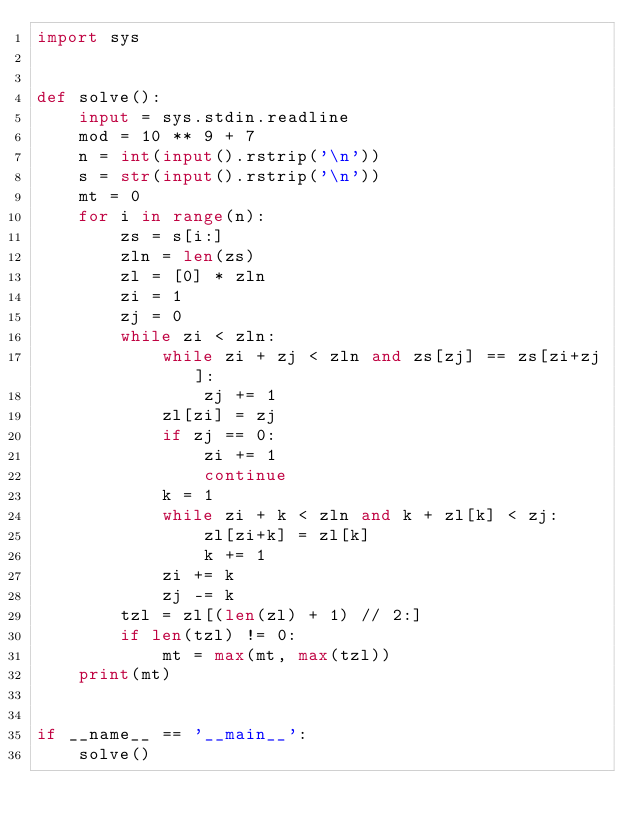Convert code to text. <code><loc_0><loc_0><loc_500><loc_500><_Python_>import sys


def solve():
    input = sys.stdin.readline
    mod = 10 ** 9 + 7
    n = int(input().rstrip('\n'))
    s = str(input().rstrip('\n'))
    mt = 0
    for i in range(n):
        zs = s[i:]
        zln = len(zs)
        zl = [0] * zln
        zi = 1
        zj = 0
        while zi < zln:
            while zi + zj < zln and zs[zj] == zs[zi+zj]:
                zj += 1
            zl[zi] = zj
            if zj == 0:
                zi += 1
                continue
            k = 1
            while zi + k < zln and k + zl[k] < zj:
                zl[zi+k] = zl[k]
                k += 1
            zi += k
            zj -= k
        tzl = zl[(len(zl) + 1) // 2:]
        if len(tzl) != 0:
            mt = max(mt, max(tzl))
    print(mt)


if __name__ == '__main__':
    solve()
</code> 